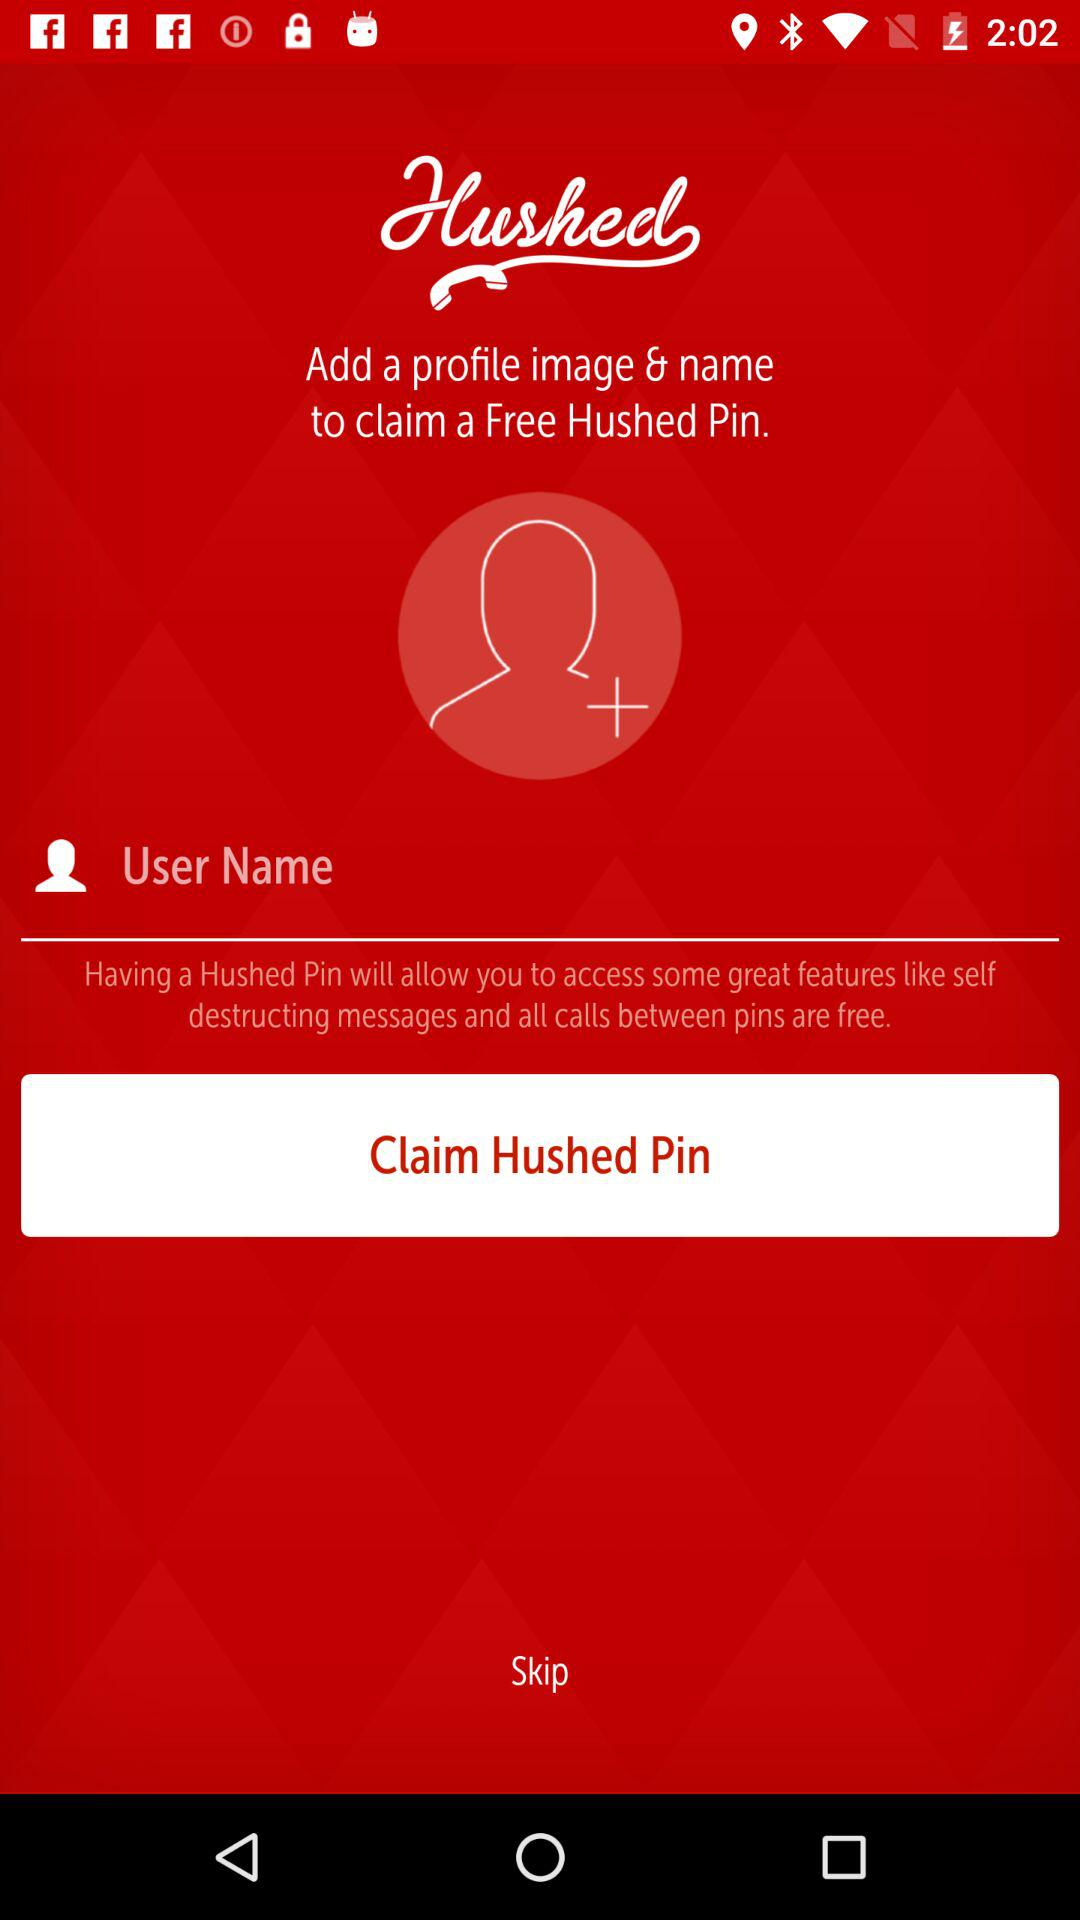What is the application name? The application name is "Hushed". 